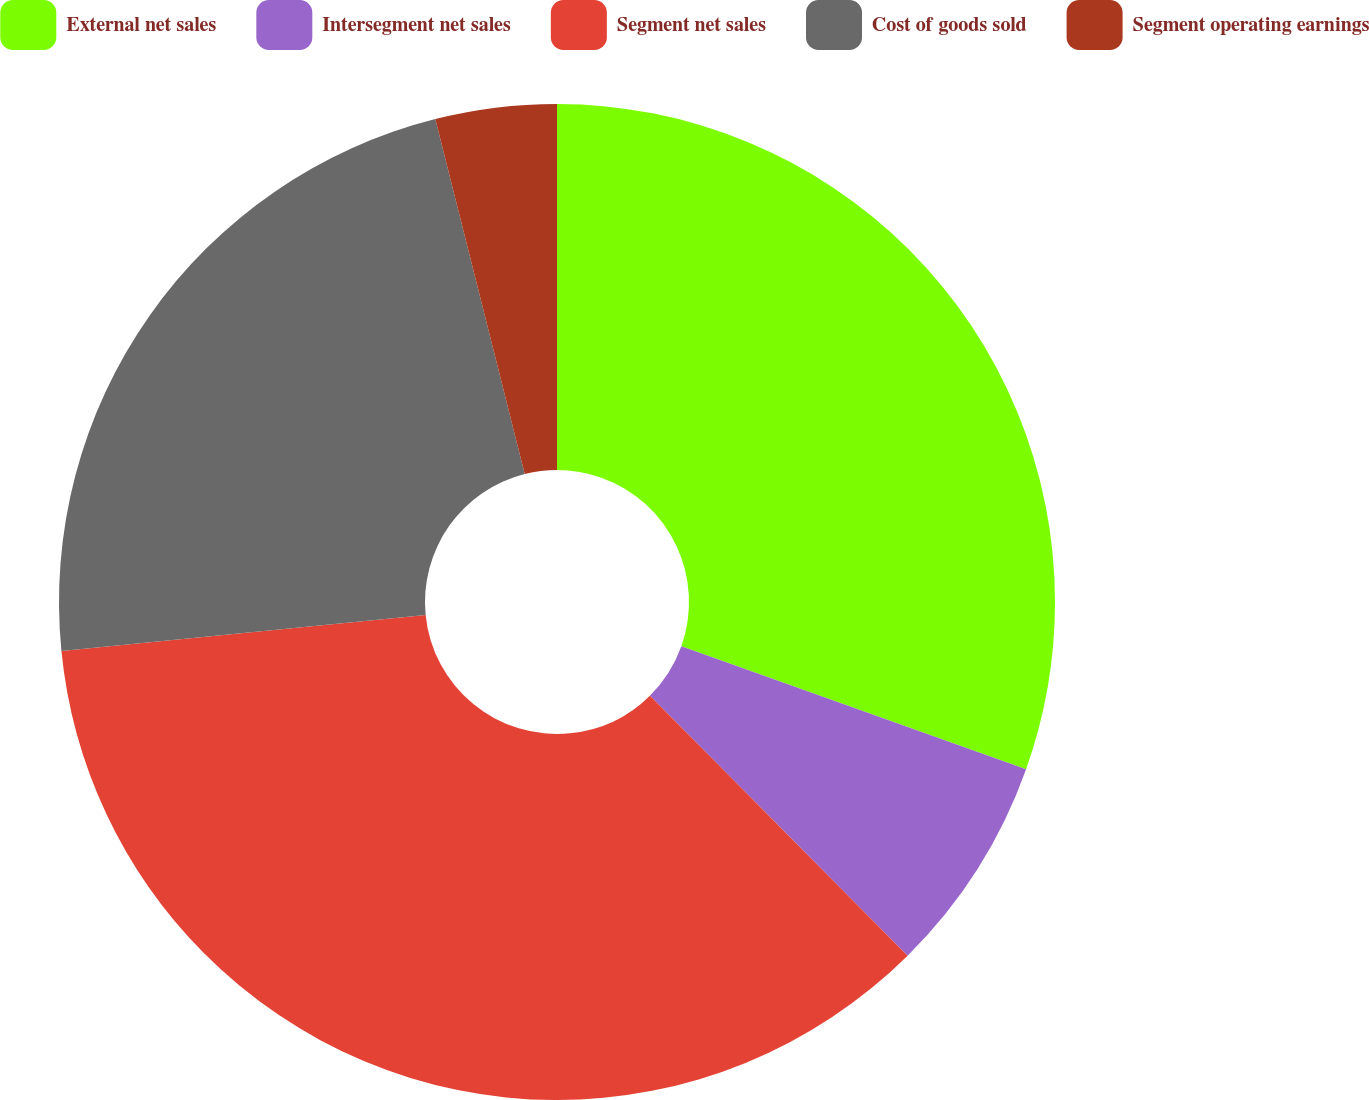Convert chart to OTSL. <chart><loc_0><loc_0><loc_500><loc_500><pie_chart><fcel>External net sales<fcel>Intersegment net sales<fcel>Segment net sales<fcel>Cost of goods sold<fcel>Segment operating earnings<nl><fcel>30.45%<fcel>7.12%<fcel>35.86%<fcel>22.64%<fcel>3.93%<nl></chart> 